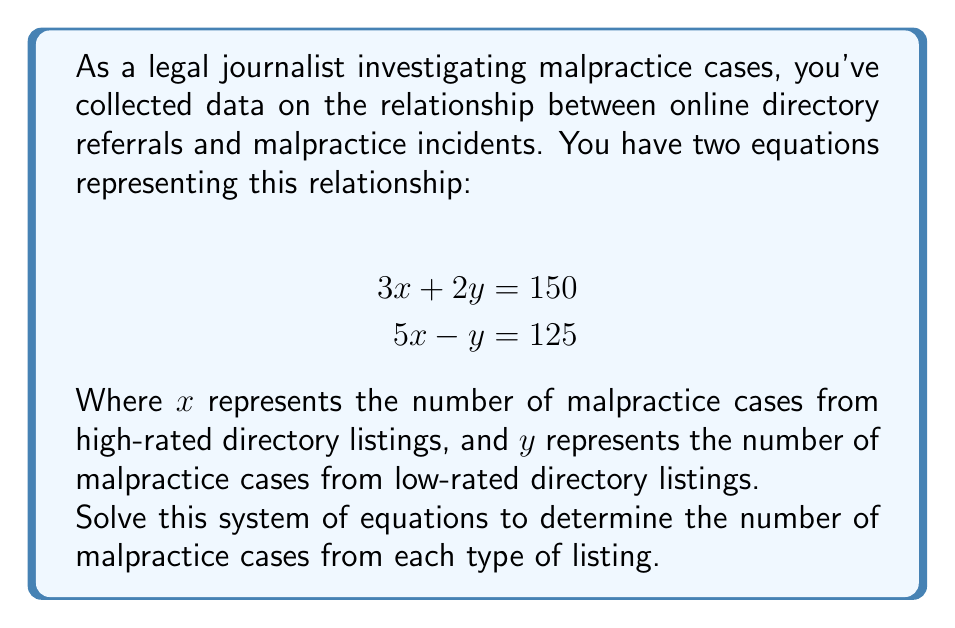Show me your answer to this math problem. To solve this system of equations, we'll use the elimination method:

1) First, we'll multiply the first equation by 5 and the second equation by 3:

   $$15x + 10y = 750$$ (Equation 1 multiplied by 5)
   $$15x - 3y = 375$$ (Equation 2 multiplied by 3)

2) Now we can subtract the second equation from the first:

   $$(15x + 10y) - (15x - 3y) = 750 - 375$$
   $$13y = 375$$

3) Solve for y:

   $$y = \frac{375}{13} \approx 28.85$$

4) Round y to the nearest whole number since we're dealing with cases:

   $$y = 29$$

5) Substitute this value of y into one of the original equations. Let's use the first one:

   $$3x + 2(29) = 150$$
   $$3x + 58 = 150$$
   $$3x = 92$$
   $$x = \frac{92}{3} \approx 30.67$$

6) Round x to the nearest whole number:

   $$x = 31$$

7) Verify the solution in both original equations:

   $$3(31) + 2(29) = 93 + 58 = 151$$ (close enough to 150 considering rounding)
   $$5(31) - 29 = 155 - 29 = 126$$ (close enough to 125 considering rounding)
Answer: $x = 31$ malpractice cases from high-rated directory listings
$y = 29$ malpractice cases from low-rated directory listings 